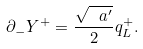Convert formula to latex. <formula><loc_0><loc_0><loc_500><loc_500>\partial _ { - } Y ^ { + } = \frac { \sqrt { \ a ^ { \prime } } } { 2 } q ^ { + } _ { L } .</formula> 